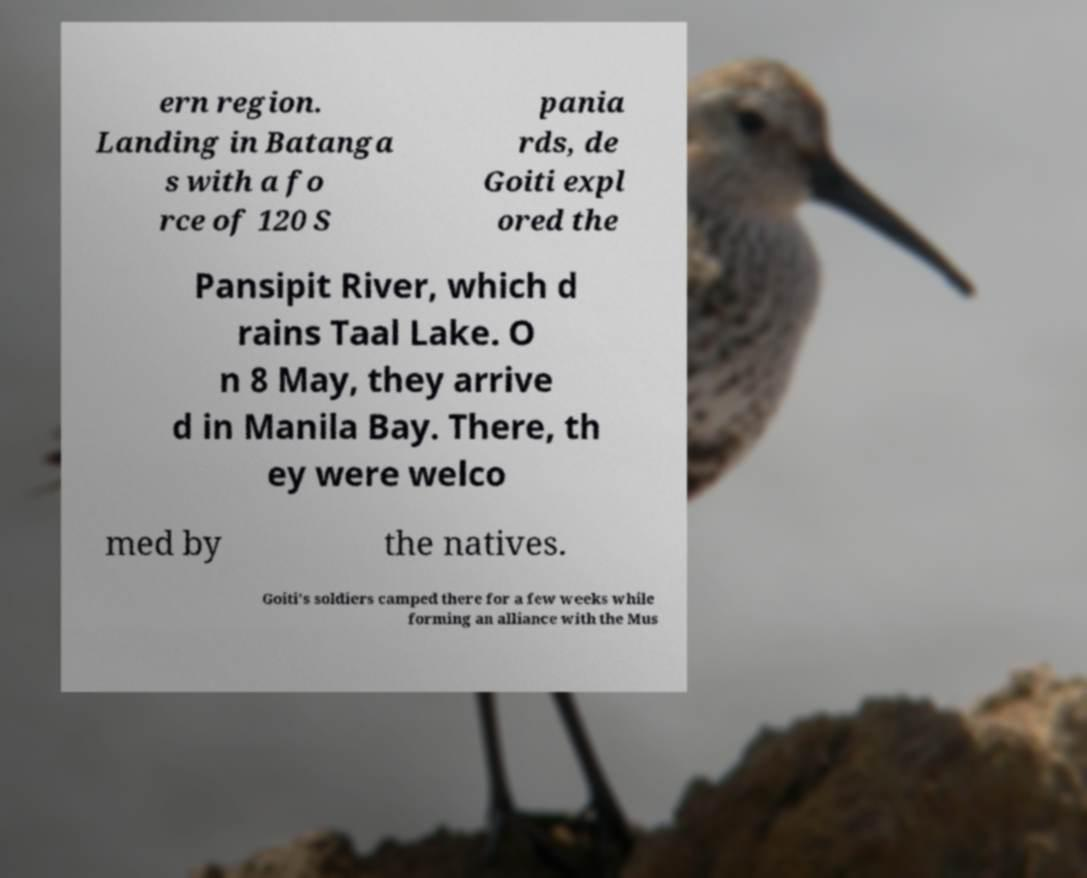Please identify and transcribe the text found in this image. ern region. Landing in Batanga s with a fo rce of 120 S pania rds, de Goiti expl ored the Pansipit River, which d rains Taal Lake. O n 8 May, they arrive d in Manila Bay. There, th ey were welco med by the natives. Goiti's soldiers camped there for a few weeks while forming an alliance with the Mus 